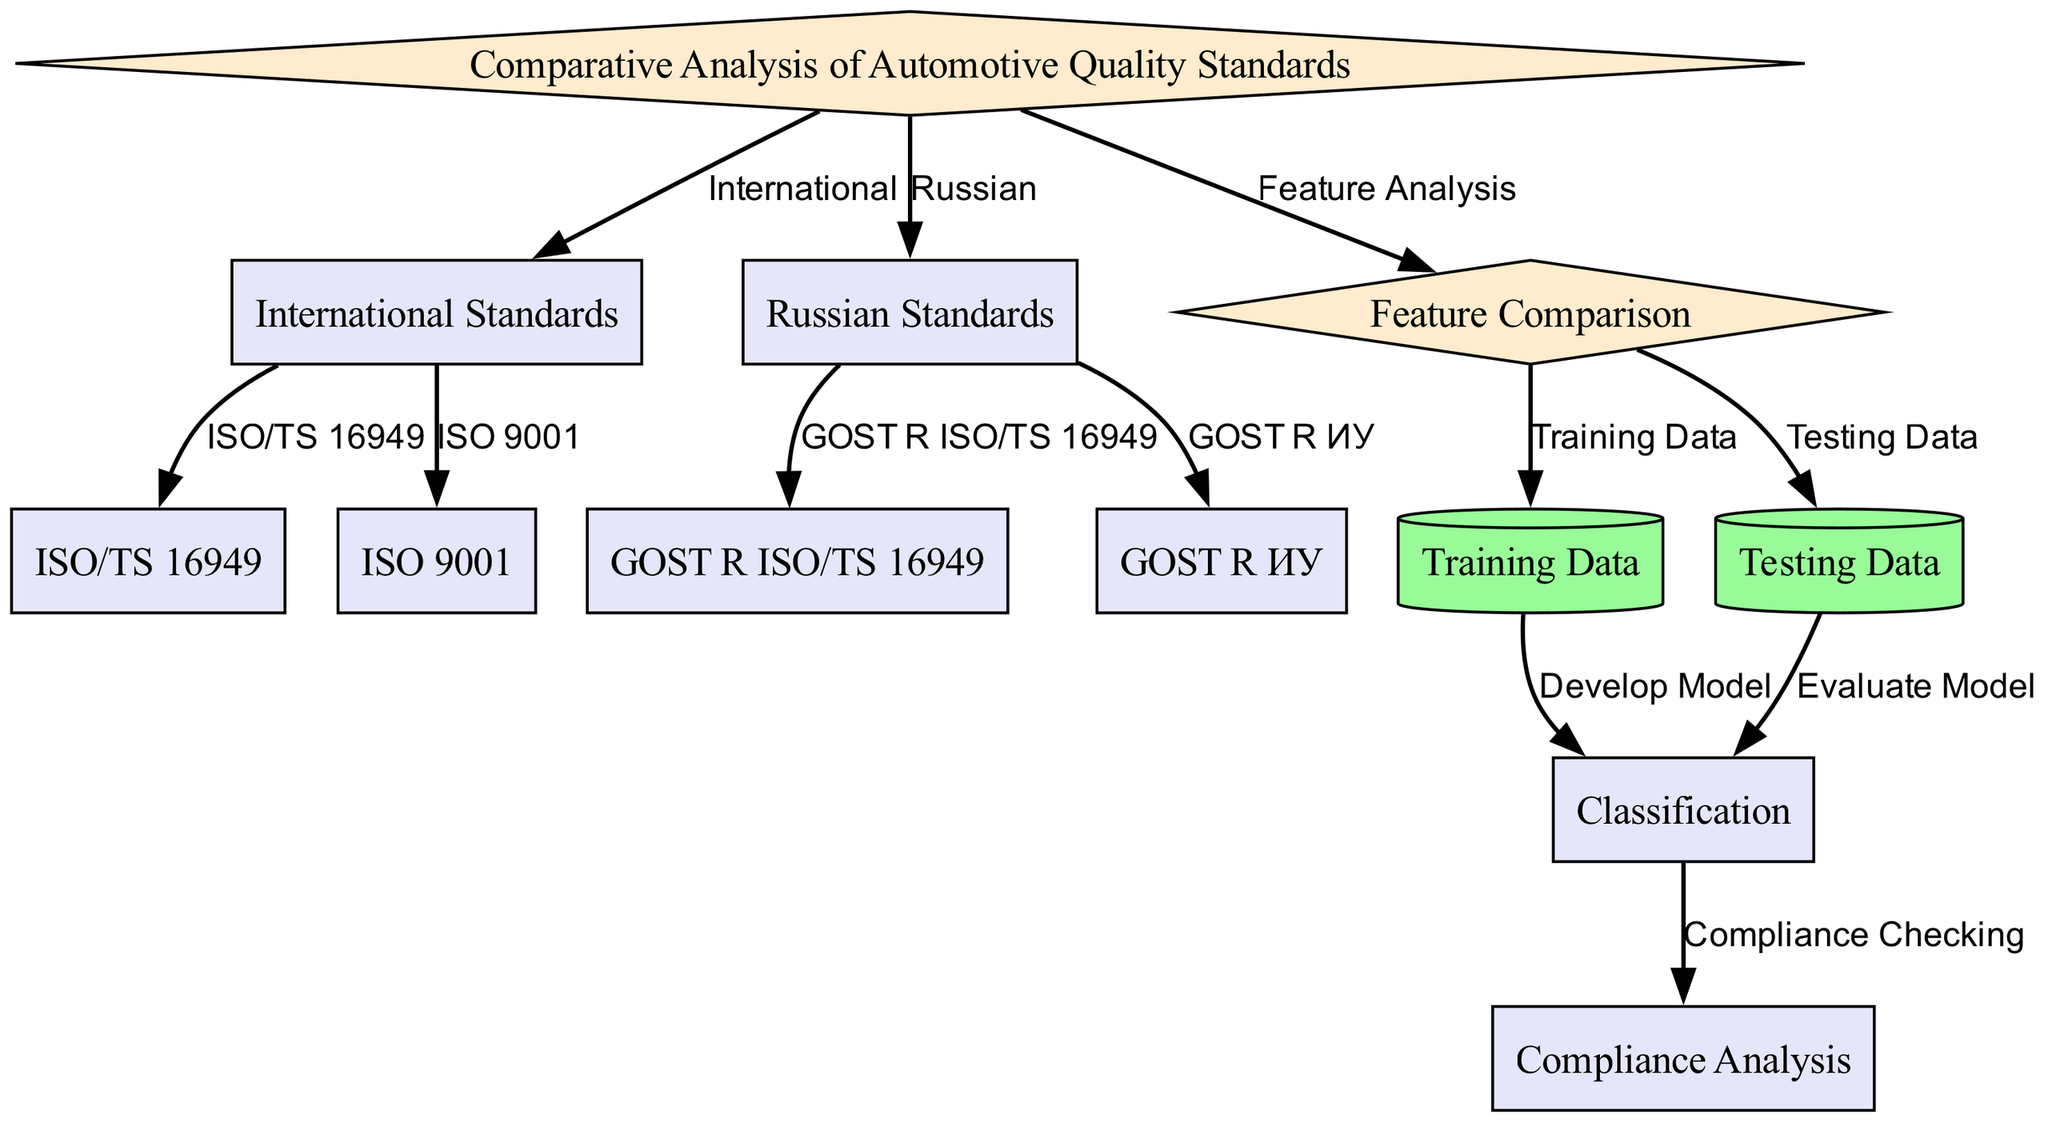What is the root node label? The root node is labeled "Comparative Analysis of Automotive Quality Standards", which is the top node in the diagram that describes the overall focus of the analysis.
Answer: Comparative Analysis of Automotive Quality Standards How many international standards are represented in the diagram? There are two international standards represented in the diagram: ISO/TS 16949 and ISO 9001. They are child nodes under the International Standards node.
Answer: 2 What labels are associated with the Russian standards? The Russian standards labeled in the diagram are GOST R ISO/TS 16949 and GOST R ИУ. These are connected directly under the Russian Standards node.
Answer: GOST R ISO/TS 16949, GOST R ИУ What does the feature comparison node connect to? The feature comparison node connects to both training data and testing data nodes, showing that it leads to the analysis and preparation of data for the model development phase.
Answer: Training Data, Testing Data Which process comes after the classification step? The process that follows the classification step is the compliance analysis, as indicated by the directed edge leading from classification to compliance analysis.
Answer: Compliance Analysis What is the total number of nodes in the diagram? Counting all nodes, we have ten separate nodes that illustrate the different aspects of the comparative analysis. These include various standards and stages in the procedure.
Answer: 10 What is the relationship between training data and classification? The training data is used to develop a model, which is indicated in the diagram by a directed edge from training data to classification, representing the flow of data into the modeling phase.
Answer: Develop Model Which edge type connects the Russian standards to their respective nodes? The edge type that connects the Russian standards to their respective nodes is labeled with "GOST R ISO/TS 16949" and "GOST R ИУ", indicating their specific standards in relation to Russian regulations.
Answer: GOST R ISO/TS 16949, GOST R ИУ How many edges are depicted in the diagram? There are nine edges shown in the diagram, which represent the relationships and flow between the various nodes and processes illustrated in the analysis.
Answer: 9 